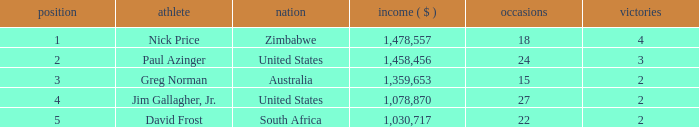How many events are in South Africa? 22.0. 